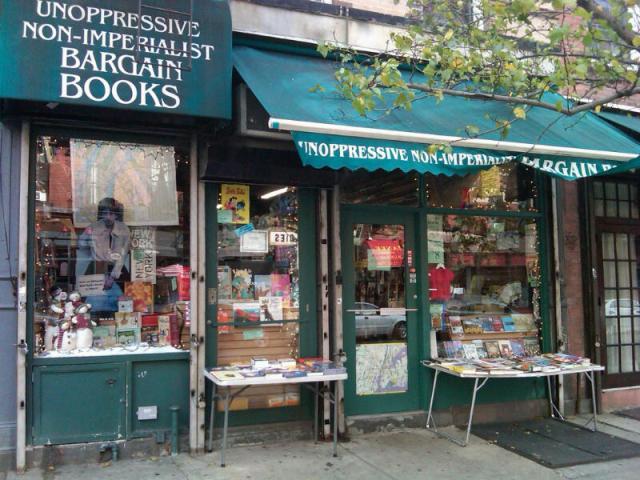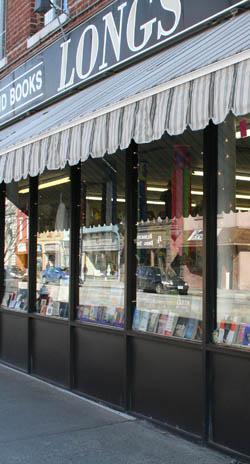The first image is the image on the left, the second image is the image on the right. Analyze the images presented: Is the assertion "In one image, an awning with advertising extends over the front of a bookstore." valid? Answer yes or no. Yes. 